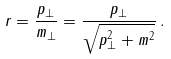<formula> <loc_0><loc_0><loc_500><loc_500>r = \frac { p _ { \perp } } { m _ { \perp } } = \frac { p _ { \perp } } { \sqrt { p _ { \perp } ^ { 2 } + m ^ { 2 } } } \, .</formula> 